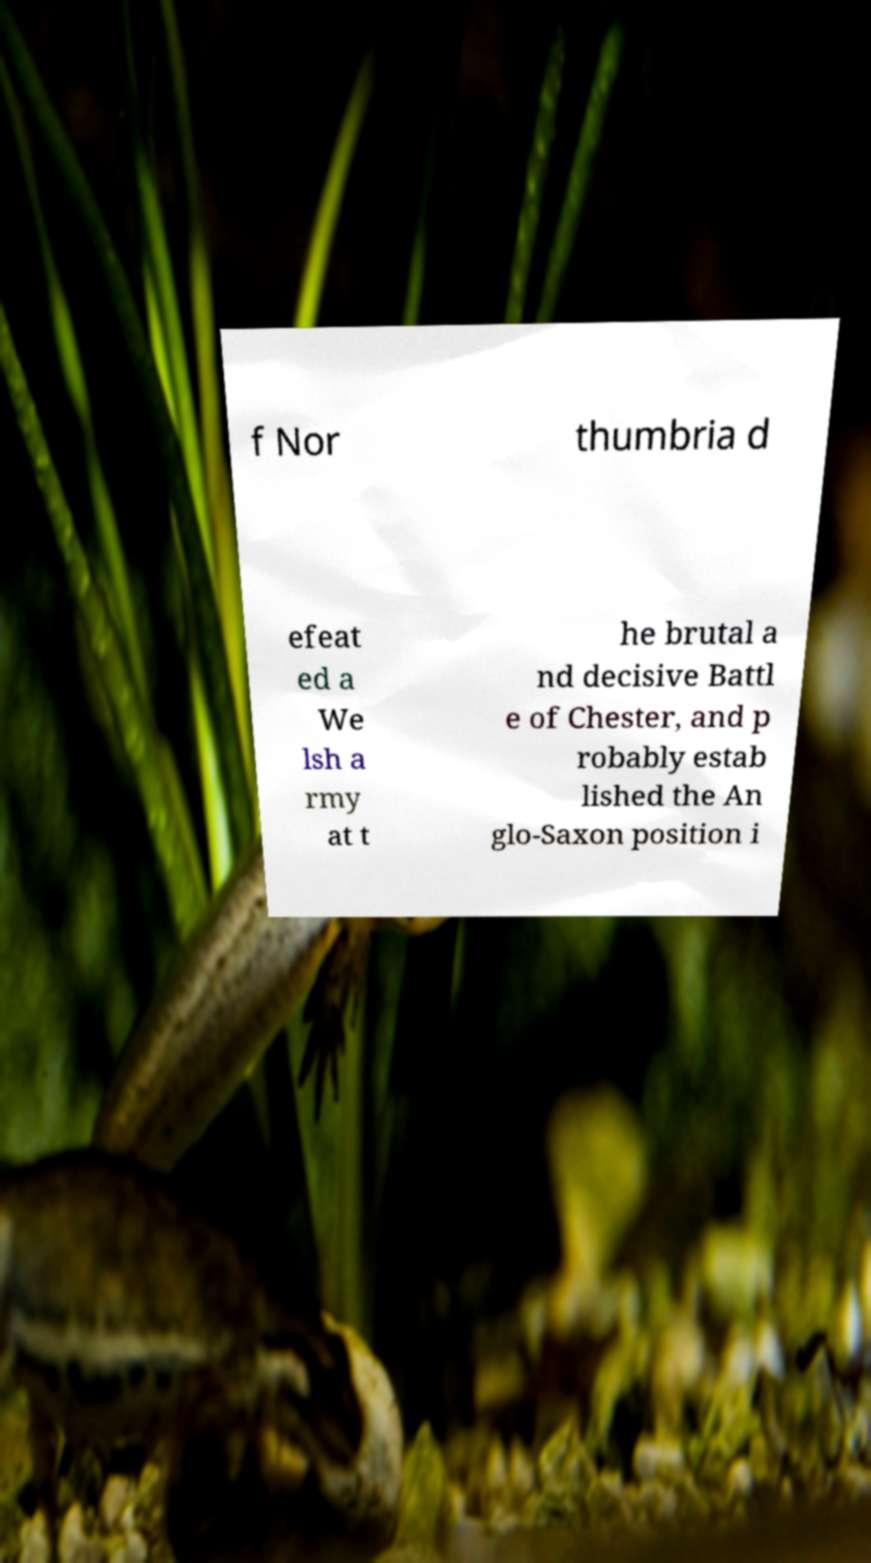Please identify and transcribe the text found in this image. f Nor thumbria d efeat ed a We lsh a rmy at t he brutal a nd decisive Battl e of Chester, and p robably estab lished the An glo-Saxon position i 